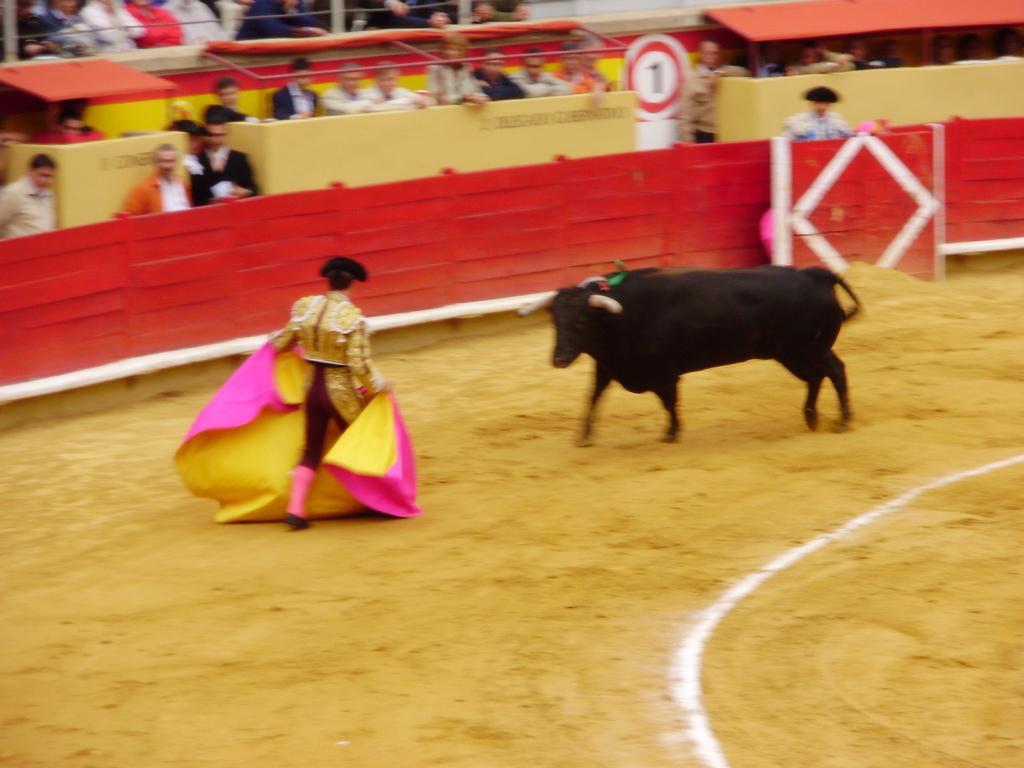Can you describe this image briefly? This image is taken outdoors. At the bottom of the image there is a ground. In the background there is a wooden fence. There is a wall. Many people are standing and there is a tent. In the middle of the image there is a bull and a man is walking on the ground. He is holding a cloth in his hands. 